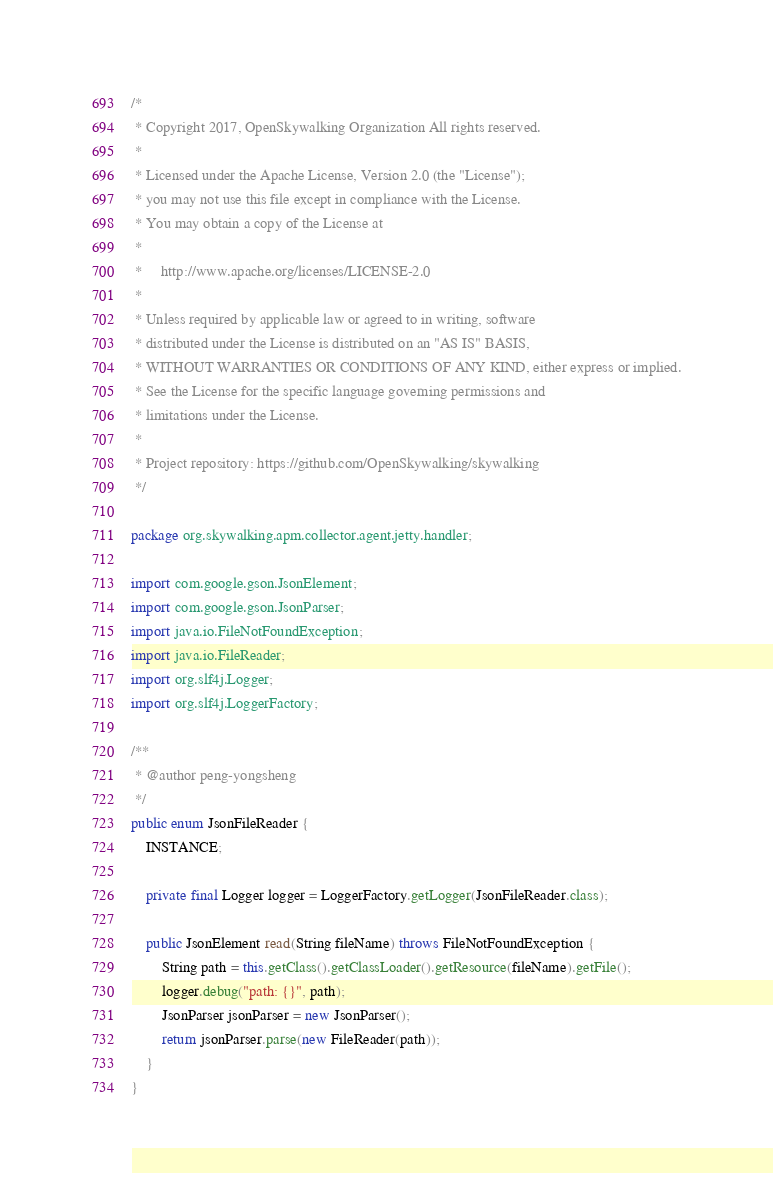Convert code to text. <code><loc_0><loc_0><loc_500><loc_500><_Java_>/*
 * Copyright 2017, OpenSkywalking Organization All rights reserved.
 *
 * Licensed under the Apache License, Version 2.0 (the "License");
 * you may not use this file except in compliance with the License.
 * You may obtain a copy of the License at
 *
 *     http://www.apache.org/licenses/LICENSE-2.0
 *
 * Unless required by applicable law or agreed to in writing, software
 * distributed under the License is distributed on an "AS IS" BASIS,
 * WITHOUT WARRANTIES OR CONDITIONS OF ANY KIND, either express or implied.
 * See the License for the specific language governing permissions and
 * limitations under the License.
 *
 * Project repository: https://github.com/OpenSkywalking/skywalking
 */

package org.skywalking.apm.collector.agent.jetty.handler;

import com.google.gson.JsonElement;
import com.google.gson.JsonParser;
import java.io.FileNotFoundException;
import java.io.FileReader;
import org.slf4j.Logger;
import org.slf4j.LoggerFactory;

/**
 * @author peng-yongsheng
 */
public enum JsonFileReader {
    INSTANCE;

    private final Logger logger = LoggerFactory.getLogger(JsonFileReader.class);

    public JsonElement read(String fileName) throws FileNotFoundException {
        String path = this.getClass().getClassLoader().getResource(fileName).getFile();
        logger.debug("path: {}", path);
        JsonParser jsonParser = new JsonParser();
        return jsonParser.parse(new FileReader(path));
    }
}
</code> 